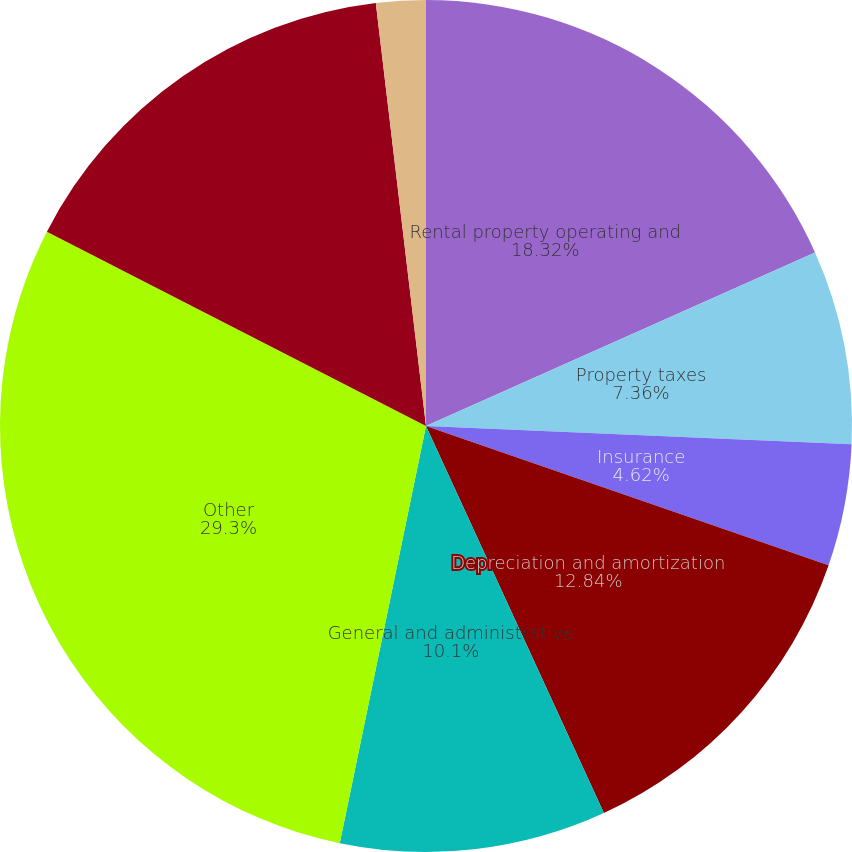Convert chart. <chart><loc_0><loc_0><loc_500><loc_500><pie_chart><fcel>Rental property operating and<fcel>Property taxes<fcel>Insurance<fcel>Depreciation and amortization<fcel>General and administrative<fcel>Other<fcel>Total operating expenses<fcel>Interest expense<nl><fcel>18.32%<fcel>7.36%<fcel>4.62%<fcel>12.84%<fcel>10.1%<fcel>29.29%<fcel>15.58%<fcel>1.88%<nl></chart> 